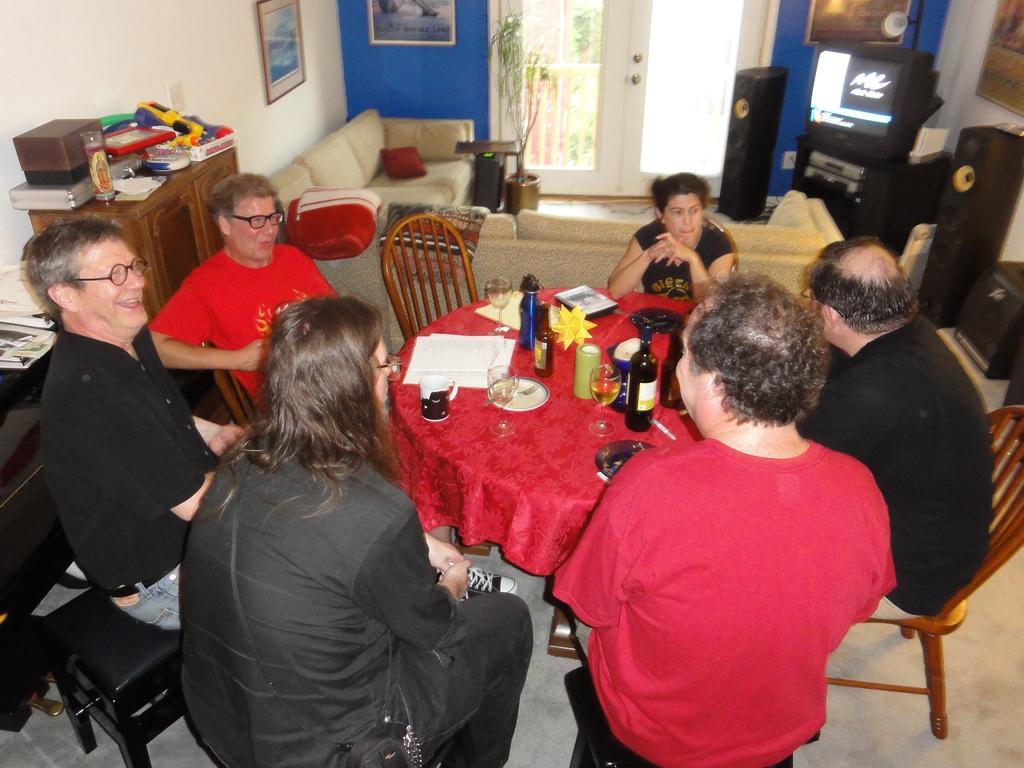How would you summarize this image in a sentence or two? There are six members sitting in the chairs around a table on which a plate papers, glasses and some bottles were placed. In the background, there is a sofa, doors and a wall here. We can observe a television too. 